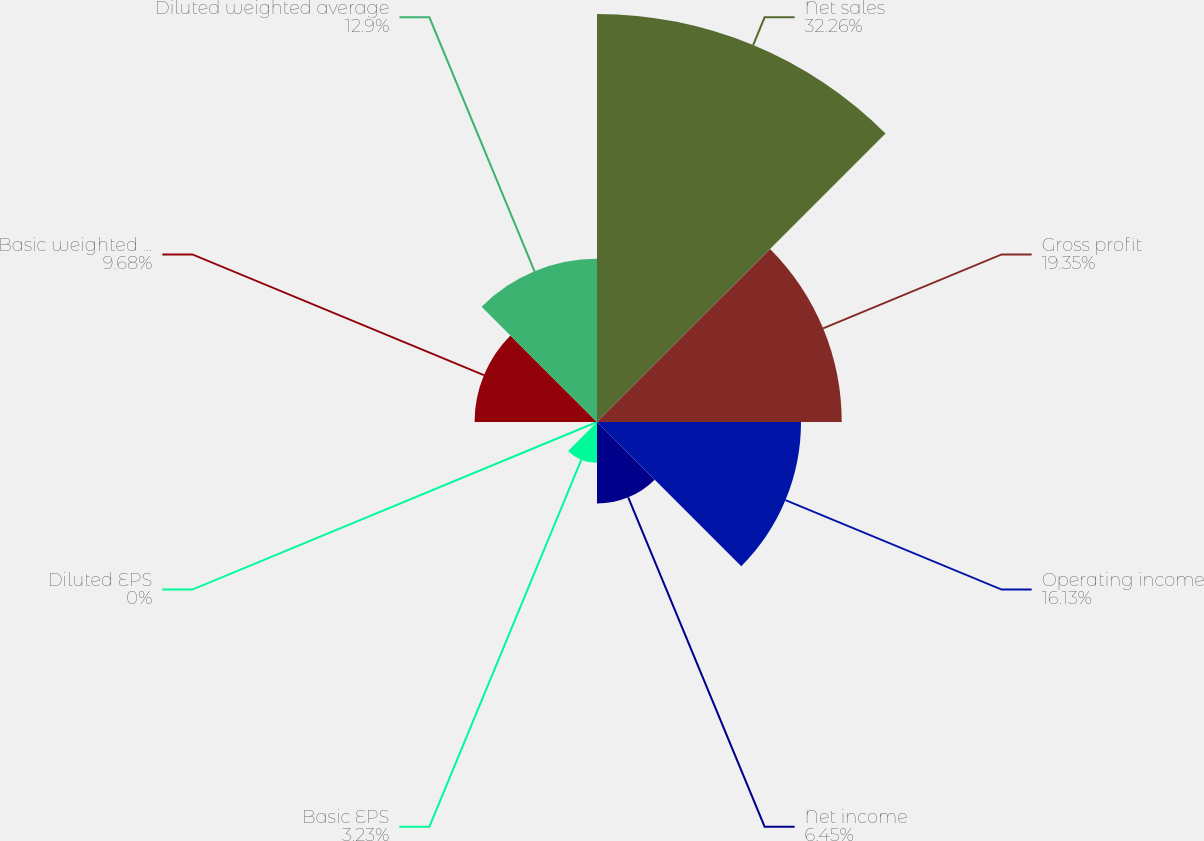Convert chart. <chart><loc_0><loc_0><loc_500><loc_500><pie_chart><fcel>Net sales<fcel>Gross profit<fcel>Operating income<fcel>Net income<fcel>Basic EPS<fcel>Diluted EPS<fcel>Basic weighted average shares<fcel>Diluted weighted average<nl><fcel>32.26%<fcel>19.35%<fcel>16.13%<fcel>6.45%<fcel>3.23%<fcel>0.0%<fcel>9.68%<fcel>12.9%<nl></chart> 